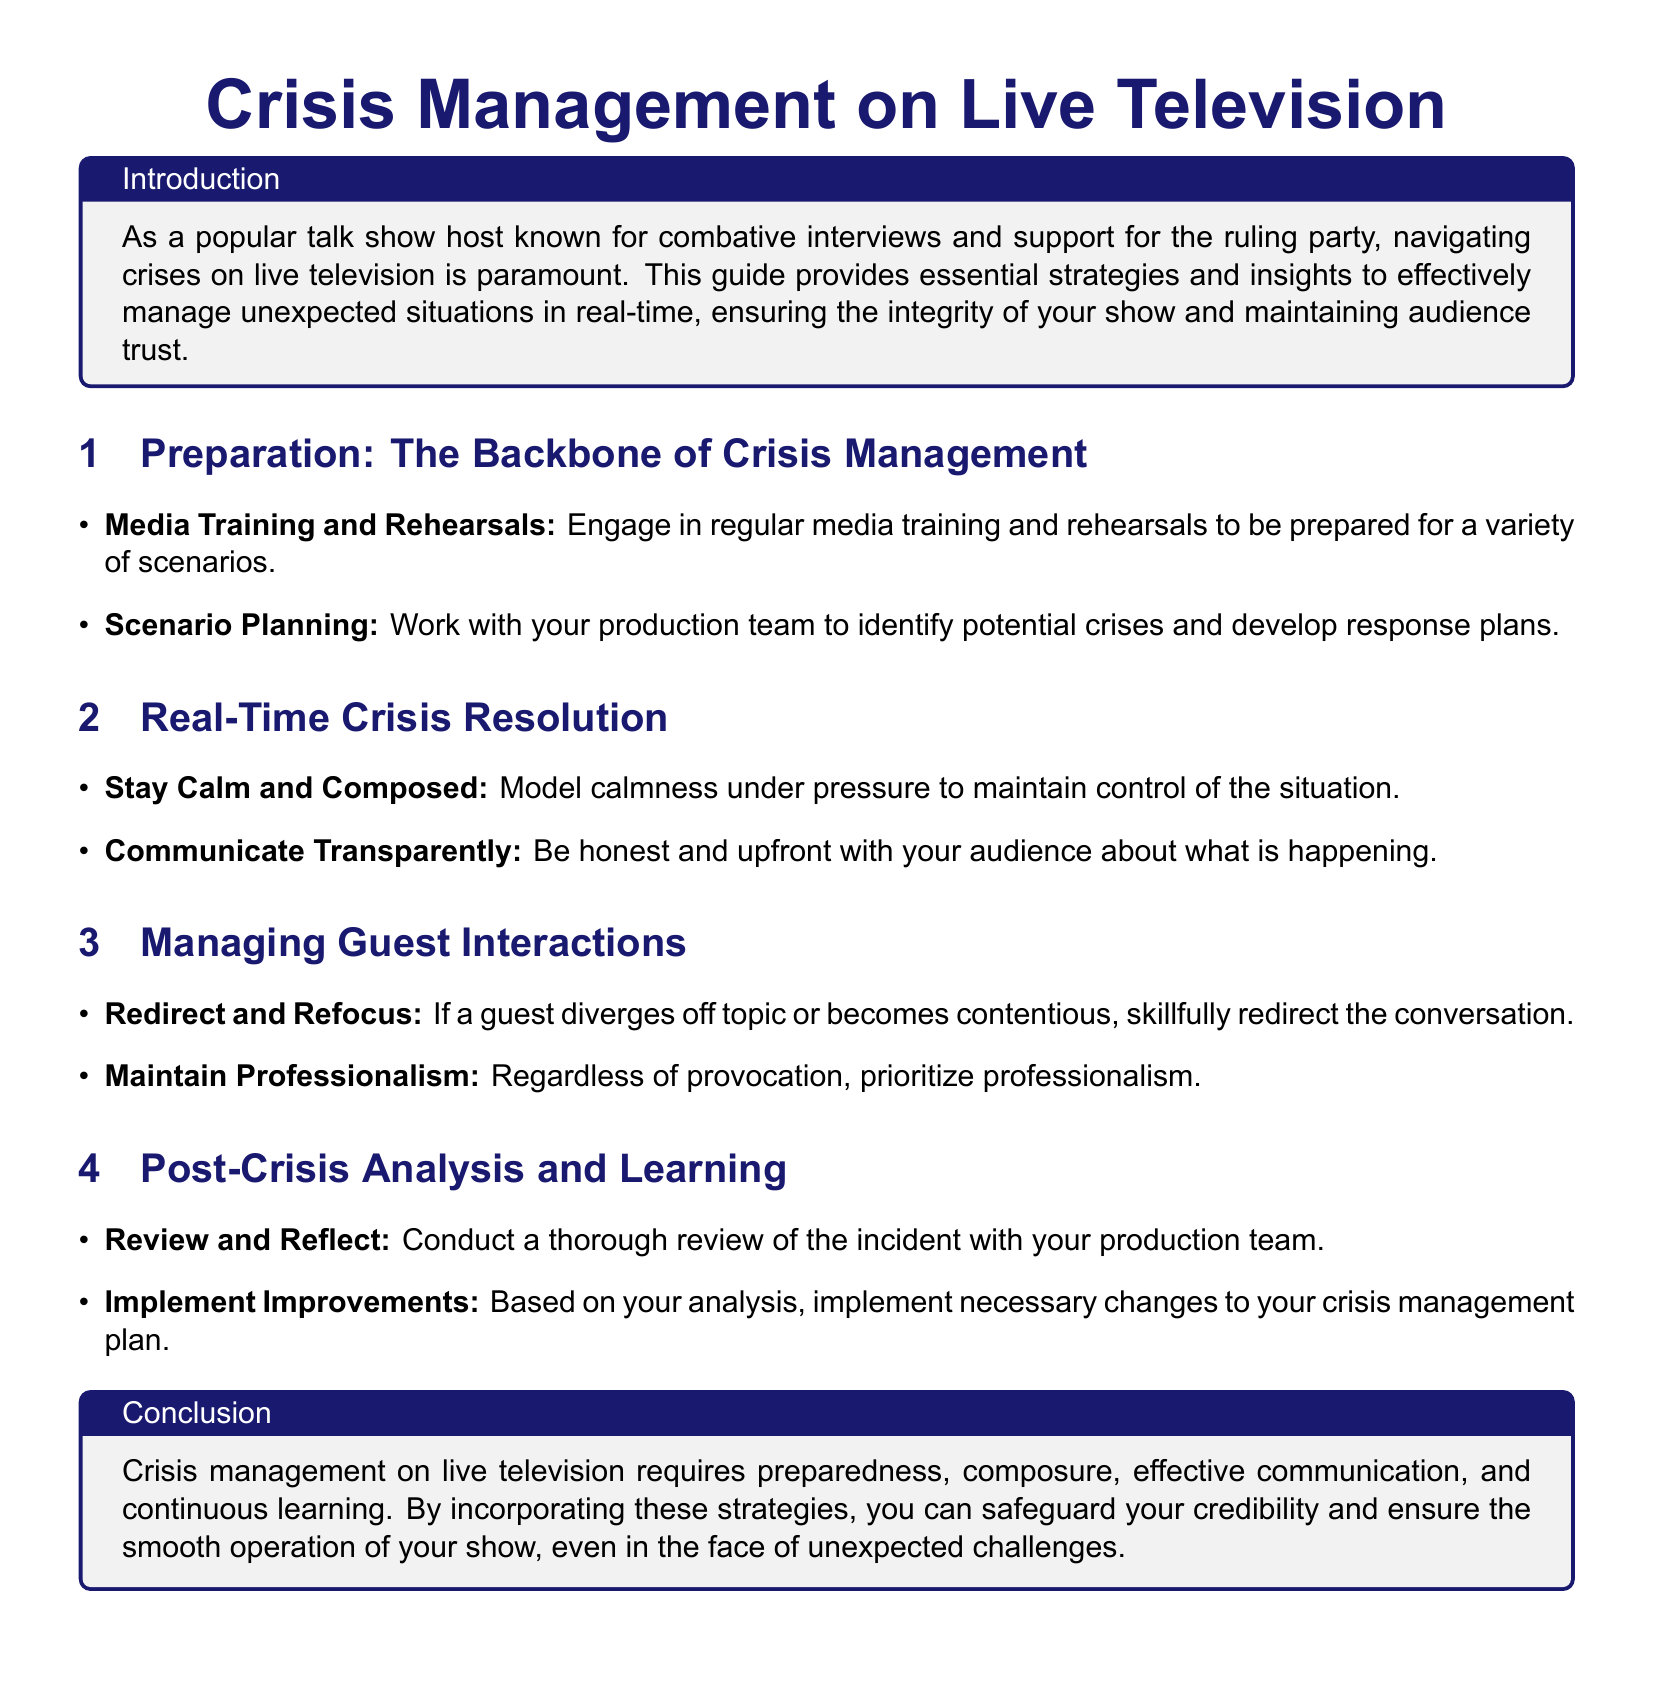What is the title of the document? The title is prominently displayed at the top of the document, indicating its main focus area.
Answer: Crisis Management on Live Television What section discusses preparation strategies? The document clearly outlines various aspects of preparation that are crucial for crisis management.
Answer: Preparation: The Backbone of Crisis Management Which essential quality is emphasized for hosts during a crisis? The document highlights the importance of maintaining composure in stressful situations, which is vital for effective crisis management.
Answer: Stay Calm and Composed What approach should hosts take toward guest interactions in a crisis? The guide advises on how to handle guests during unexpected situations, highlighting a specific technique.
Answer: Redirect and Refocus What should hosts do after a crisis has occurred? The document suggests a systematic approach to learning from the experience following a crisis.
Answer: Review and Reflect What is the color scheme used for the headings? The document uses specific colors to differentiate sections, indicating a deliberate design choice in the layout.
Answer: Main color: RGB(25, 25, 112) and Secondary color: RGB(70, 130, 180) How many key areas of crisis management are outlined in the document? The document is structured into several key sections, summarizing the main elements of crisis management that are discussed.
Answer: Four What is the primary target audience for this user guide? The document is clearly aimed at a specific group of individuals who require particular skills in live broadcast settings.
Answer: Talk show hosts 